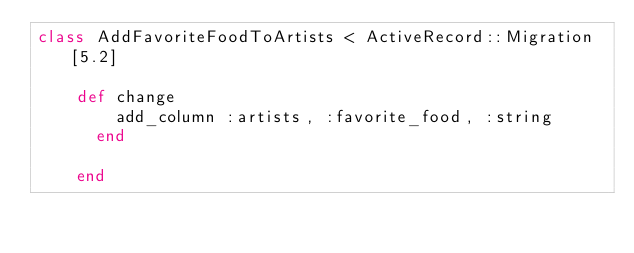<code> <loc_0><loc_0><loc_500><loc_500><_Ruby_>class AddFavoriteFoodToArtists < ActiveRecord::Migration[5.2]

    def change
        add_column :artists, :favorite_food, :string
      end
      
    end</code> 